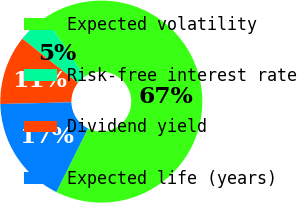Convert chart to OTSL. <chart><loc_0><loc_0><loc_500><loc_500><pie_chart><fcel>Expected volatility<fcel>Risk-free interest rate<fcel>Dividend yield<fcel>Expected life (years)<nl><fcel>66.71%<fcel>4.92%<fcel>11.1%<fcel>17.28%<nl></chart> 